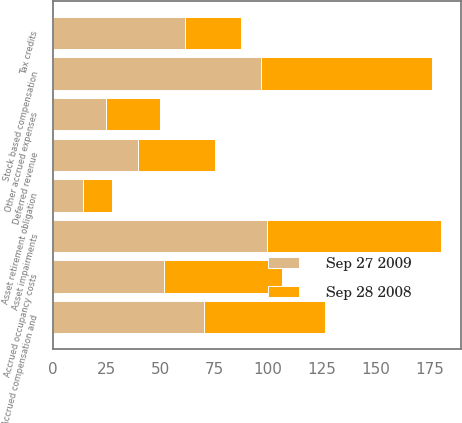Convert chart to OTSL. <chart><loc_0><loc_0><loc_500><loc_500><stacked_bar_chart><ecel><fcel>Accrued occupancy costs<fcel>Accrued compensation and<fcel>Other accrued expenses<fcel>Asset retirement obligation<fcel>Deferred revenue<fcel>Asset impairments<fcel>Tax credits<fcel>Stock based compensation<nl><fcel>Sep 27 2009<fcel>51.5<fcel>70.1<fcel>24.5<fcel>13.9<fcel>39.3<fcel>99.7<fcel>61.4<fcel>96.6<nl><fcel>Sep 28 2008<fcel>54.8<fcel>56.2<fcel>25.2<fcel>13.3<fcel>36<fcel>80.8<fcel>26.1<fcel>79.6<nl></chart> 